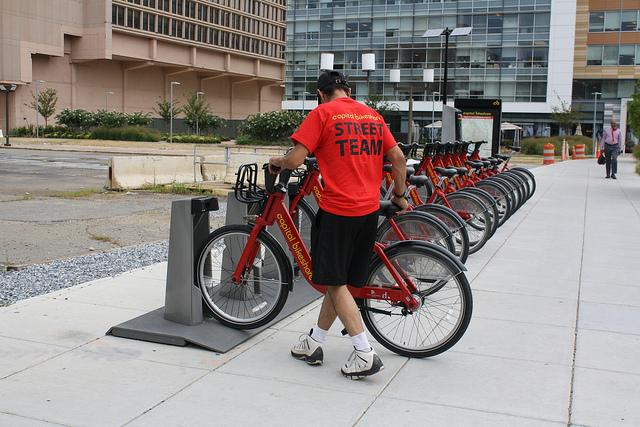What is the man standing next to the bikes most likely doing? parking bike 